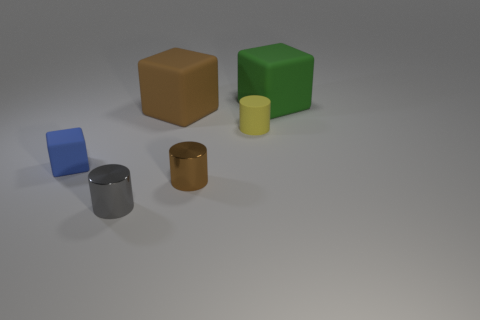Add 3 gray matte objects. How many objects exist? 9 Subtract all small yellow matte cylinders. Subtract all big yellow cylinders. How many objects are left? 5 Add 2 gray metallic objects. How many gray metallic objects are left? 3 Add 5 large rubber things. How many large rubber things exist? 7 Subtract 0 purple balls. How many objects are left? 6 